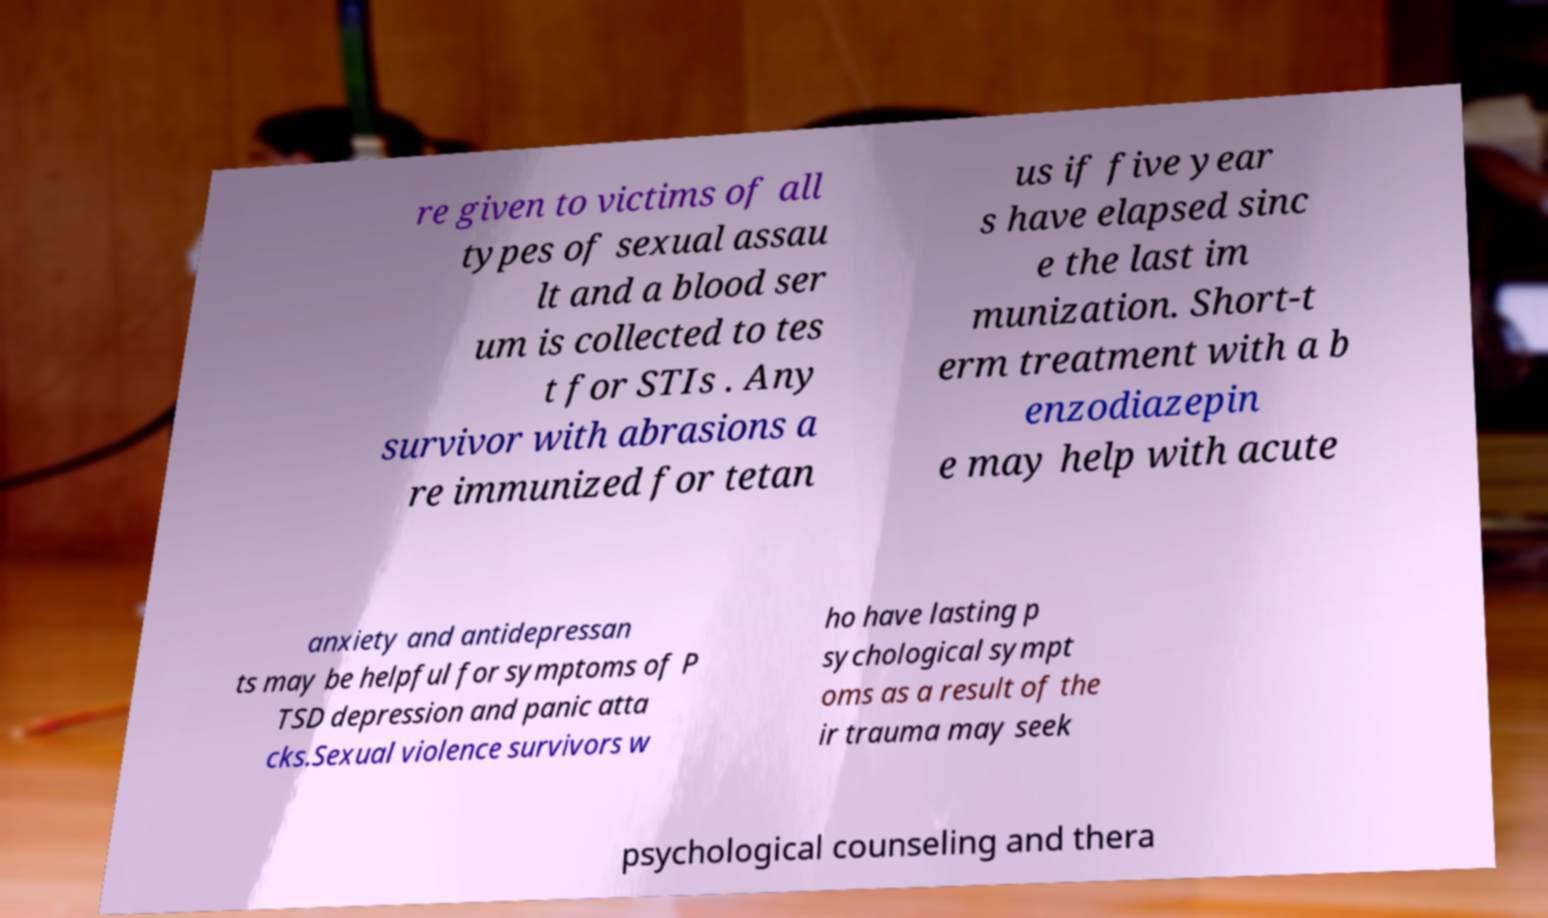Please read and relay the text visible in this image. What does it say? re given to victims of all types of sexual assau lt and a blood ser um is collected to tes t for STIs . Any survivor with abrasions a re immunized for tetan us if five year s have elapsed sinc e the last im munization. Short-t erm treatment with a b enzodiazepin e may help with acute anxiety and antidepressan ts may be helpful for symptoms of P TSD depression and panic atta cks.Sexual violence survivors w ho have lasting p sychological sympt oms as a result of the ir trauma may seek psychological counseling and thera 